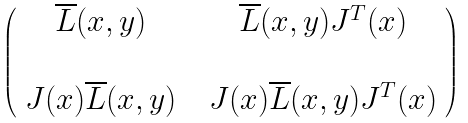Convert formula to latex. <formula><loc_0><loc_0><loc_500><loc_500>\left ( \begin{array} { c c c } \overline { L } ( x , y ) & & \overline { L } ( x , y ) J ^ { T } ( x ) \\ \\ J ( x ) \overline { L } ( x , y ) & & J ( x ) \overline { L } ( x , y ) J ^ { T } ( x ) \\ \end{array} \right )</formula> 